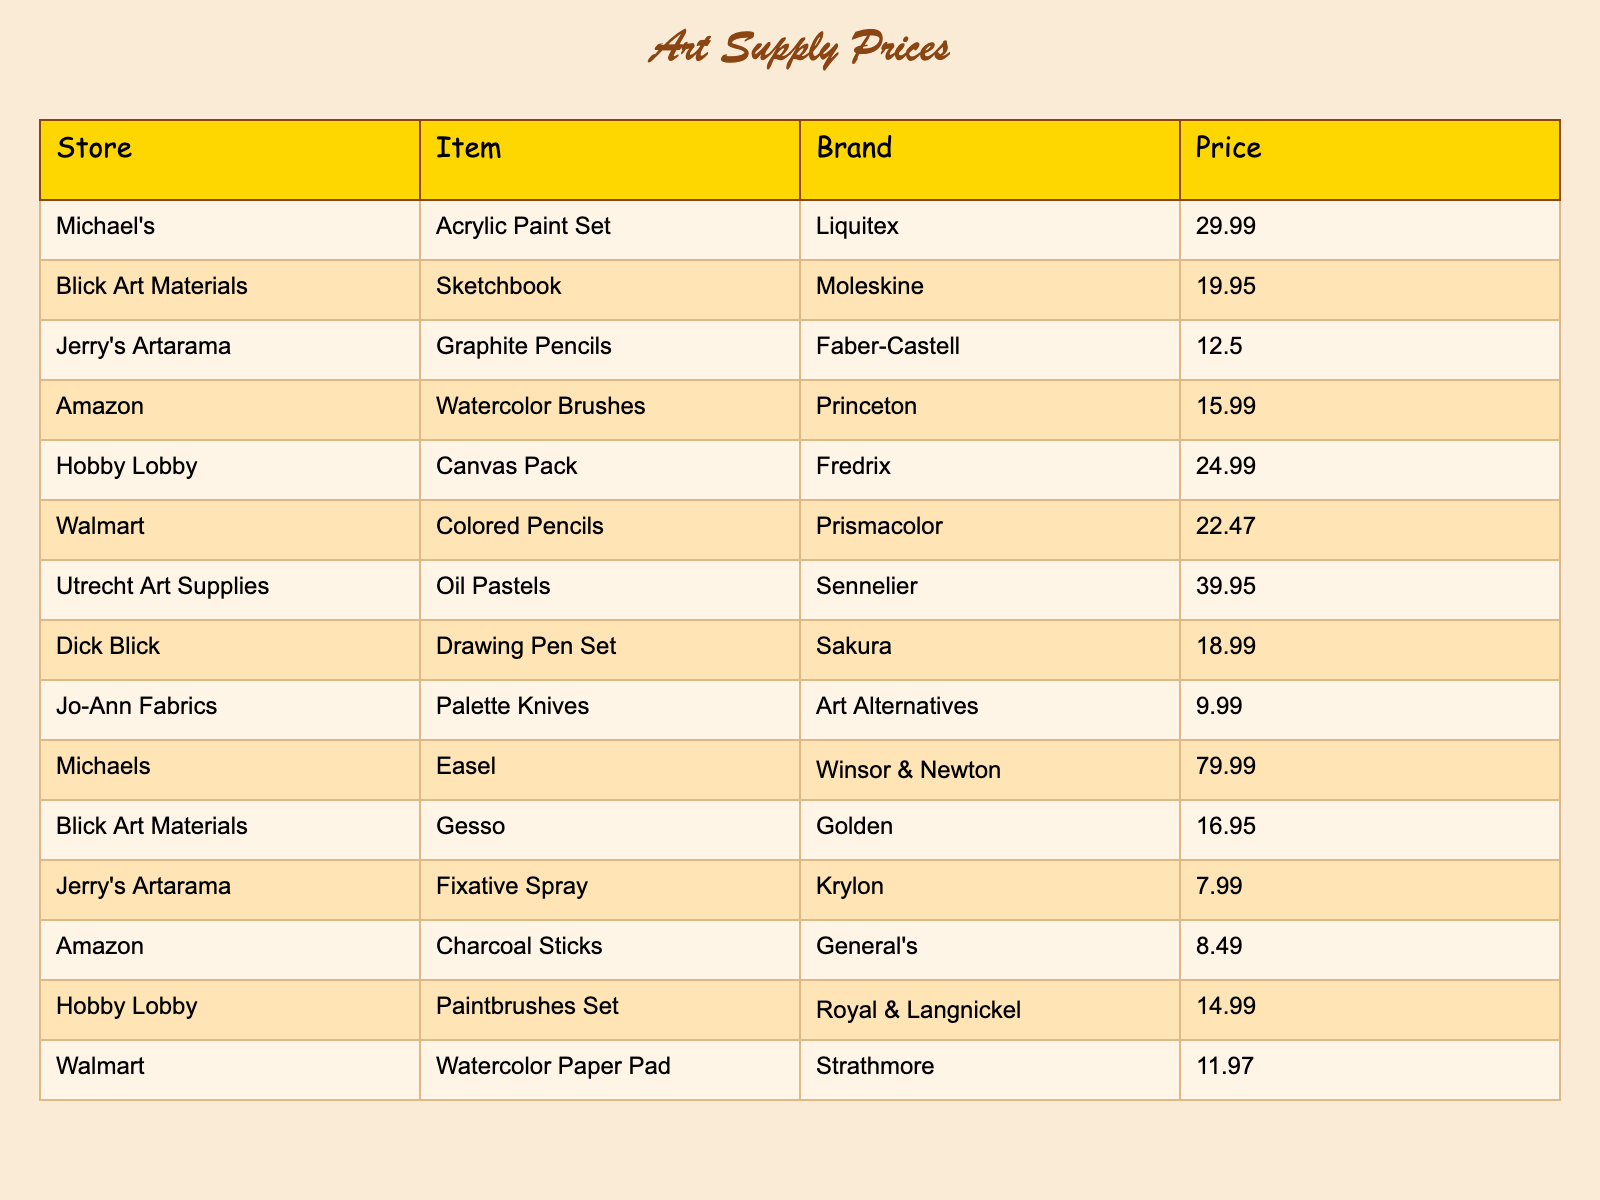What is the price of the Acrylic Paint Set from Michael's? The table shows that Michael's sells the Acrylic Paint Set by Liquitex for a price of 29.99.
Answer: 29.99 Which store offers the cheapest item, and what is it? Looking through the price column, the cheapest item is the Fixative Spray from Jerry's Artarama priced at 7.99.
Answer: Jerry's Artarama, 7.99 What is the total cost if a customer buys a Sketchbook and Graphite Pencils? The Sketchbook from Blick Art Materials costs 19.95 and the Graphite Pencils from Jerry's Artarama costs 12.50. Adding these together: 19.95 + 12.50 = 32.45.
Answer: 32.45 Is the price of the Canvas Pack from Hobby Lobby greater than that of the Oil Pastels from Utrecht Art Supplies? The Canvas Pack is priced at 24.99 and the Oil Pastels are 39.95. Since 24.99 is less than 39.95, the answer is no.
Answer: No What is the average price of all the items listed? To find the average, we first sum all prices: 29.99 + 19.95 + 12.50 + 15.99 + 24.99 + 22.47 + 39.95 + 18.99 + 9.99 + 79.99 + 16.95 + 7.99 + 8.49 + 14.99 + 11.97 = 332.32. Next, we divide this by the total number of items, which is 15. Thus, 332.32 / 15 = 22.15.
Answer: 22.15 Which item has the highest price, and at which store is it available? The highest price listed is 79.99 for the Easel from Michael's, making it the most expensive item in the table.
Answer: Michael's, 79.99 Are the prices for the Watercolor Brushes from Amazon and the Paintbrushes Set from Hobby Lobby the same? The price for Watercolor Brushes is 15.99, and for the Paintbrushes Set, it's 14.99. Since these values are not equal, the answer is no.
Answer: No How much more expensive is the Oil Pastels compared to the Colored Pencils? The Oil Pastels cost 39.95, and the Colored Pencils are 22.47. By subtracting the two prices, we get 39.95 - 22.47 = 17.48.
Answer: 17.48 What is the price range of the items listed in the table? The highest price is 79.99 (Easel) and the lowest is 7.99 (Fixative Spray). To find the range, we subtract the lowest from the highest: 79.99 - 7.99 = 72.00.
Answer: 72.00 Is there any item listed under more than one store? Each item is listed only once under its respective store, indicating there are no duplicates in the table.
Answer: No 